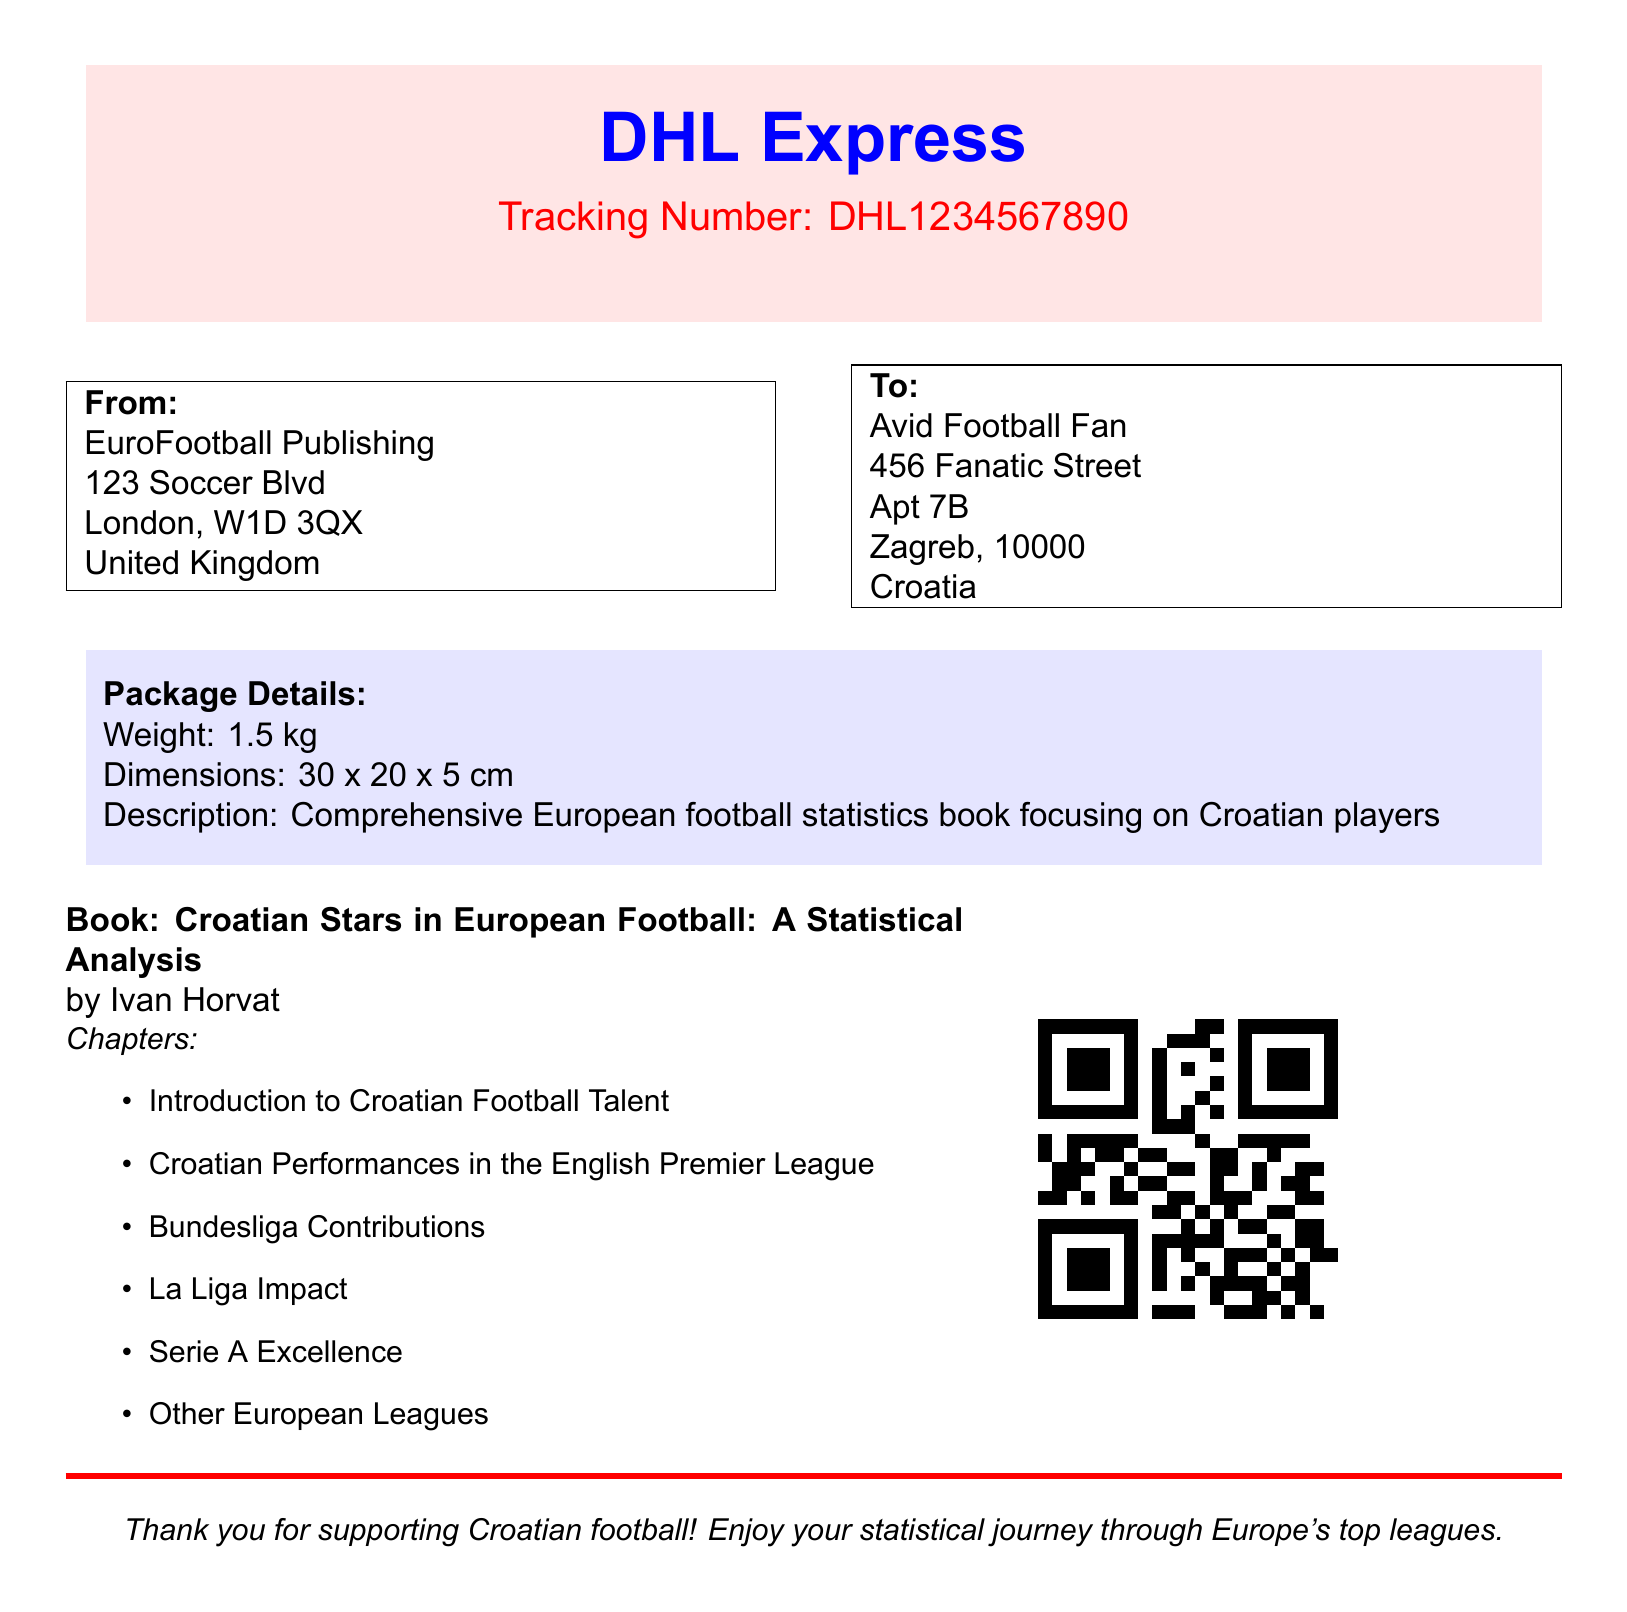what is the tracking number? The tracking number is directly stated in the document as "DHL1234567890."
Answer: DHL1234567890 who is the sender of the package? The sender's name and address are listed, which is EuroFootball Publishing located in London.
Answer: EuroFootball Publishing what is the weight of the package? The weight of the package is mentioned as 1.5 kg.
Answer: 1.5 kg what is the title of the book? The document specifies the title of the book as "Croatian Stars in European Football: A Statistical Analysis."
Answer: Croatian Stars in European Football: A Statistical Analysis how many chapters are included in the book? The chapters are listed in a bullet point format, totaling six chapters.
Answer: 6 what is the destination city for the delivery? The destination address indicates that the delivery city is Zagreb, Croatia.
Answer: Zagreb what color is the box surrounding the sender's details? The box around the sender's details is specified in the document, and it is colored.
Answer: black what genre does the book focus on? The description of the book indicates that it focuses on a specific genre related to sports statistics.
Answer: statistics who is the author of the book? The author's name is mentioned right below the title of the book.
Answer: Ivan Horvat 